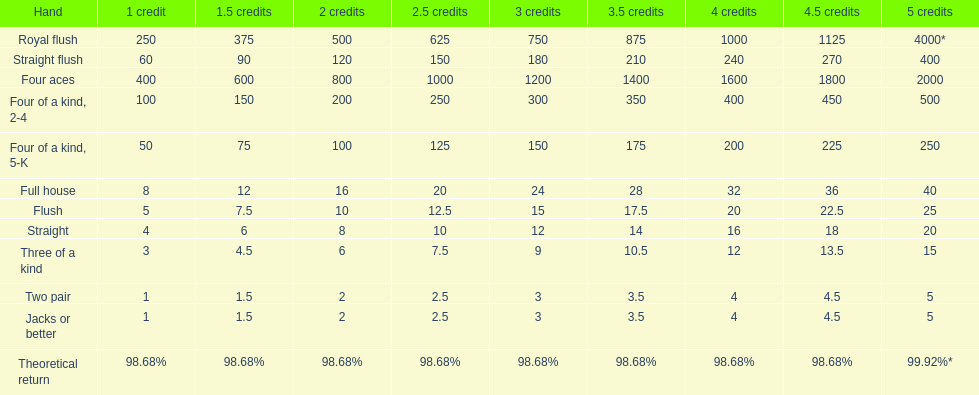What is the total amount of a 3 credit straight flush? 180. 